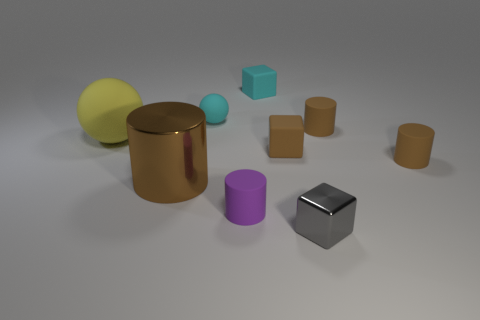Are there any small rubber blocks of the same color as the tiny matte sphere?
Give a very brief answer. Yes. What shape is the large brown object left of the cyan matte cube?
Give a very brief answer. Cylinder. The large metallic thing is what color?
Make the answer very short. Brown. The small block that is made of the same material as the large brown object is what color?
Make the answer very short. Gray. What number of small gray blocks have the same material as the tiny cyan cube?
Give a very brief answer. 0. There is a tiny cyan rubber ball; how many tiny brown matte cylinders are in front of it?
Keep it short and to the point. 2. Is the cylinder that is behind the yellow matte object made of the same material as the ball that is behind the large yellow ball?
Keep it short and to the point. Yes. Are there more small gray objects that are in front of the large brown cylinder than small purple cylinders that are behind the small cyan cube?
Your answer should be very brief. Yes. There is a cube that is the same color as the large shiny cylinder; what is its material?
Your answer should be very brief. Rubber. There is a object that is both behind the large yellow matte sphere and right of the gray cube; what material is it?
Your answer should be compact. Rubber. 